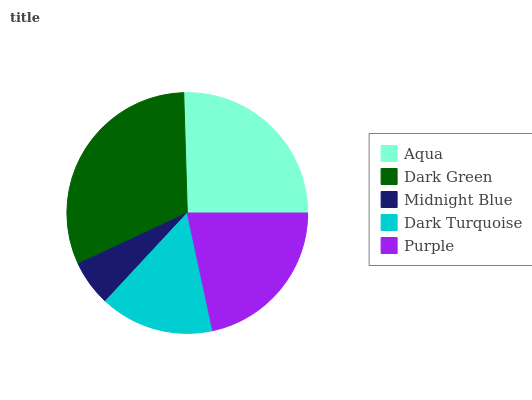Is Midnight Blue the minimum?
Answer yes or no. Yes. Is Dark Green the maximum?
Answer yes or no. Yes. Is Dark Green the minimum?
Answer yes or no. No. Is Midnight Blue the maximum?
Answer yes or no. No. Is Dark Green greater than Midnight Blue?
Answer yes or no. Yes. Is Midnight Blue less than Dark Green?
Answer yes or no. Yes. Is Midnight Blue greater than Dark Green?
Answer yes or no. No. Is Dark Green less than Midnight Blue?
Answer yes or no. No. Is Purple the high median?
Answer yes or no. Yes. Is Purple the low median?
Answer yes or no. Yes. Is Midnight Blue the high median?
Answer yes or no. No. Is Dark Green the low median?
Answer yes or no. No. 